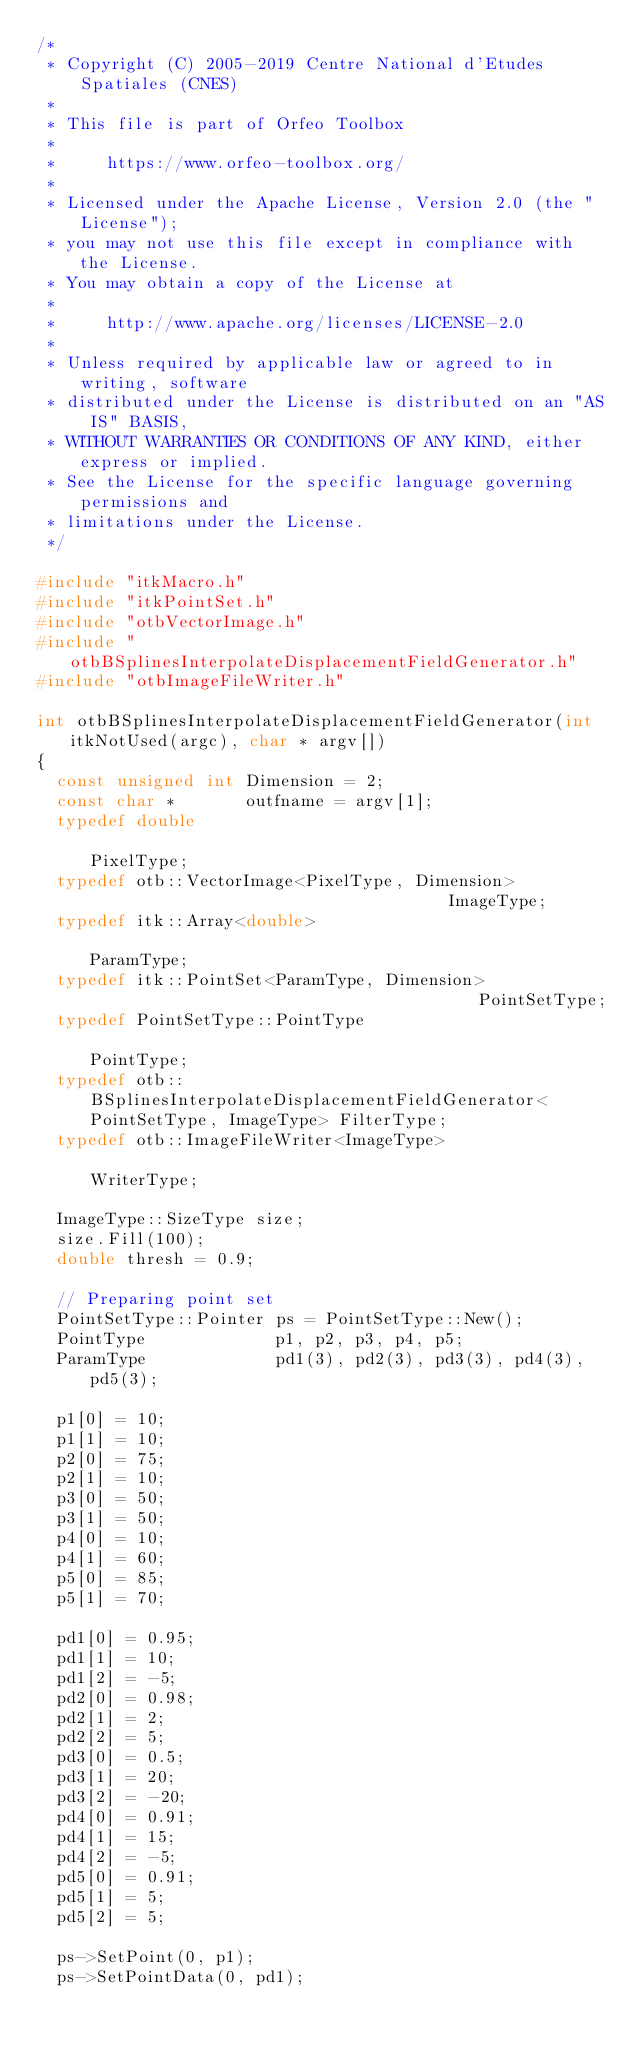<code> <loc_0><loc_0><loc_500><loc_500><_C++_>/*
 * Copyright (C) 2005-2019 Centre National d'Etudes Spatiales (CNES)
 *
 * This file is part of Orfeo Toolbox
 *
 *     https://www.orfeo-toolbox.org/
 *
 * Licensed under the Apache License, Version 2.0 (the "License");
 * you may not use this file except in compliance with the License.
 * You may obtain a copy of the License at
 *
 *     http://www.apache.org/licenses/LICENSE-2.0
 *
 * Unless required by applicable law or agreed to in writing, software
 * distributed under the License is distributed on an "AS IS" BASIS,
 * WITHOUT WARRANTIES OR CONDITIONS OF ANY KIND, either express or implied.
 * See the License for the specific language governing permissions and
 * limitations under the License.
 */

#include "itkMacro.h"
#include "itkPointSet.h"
#include "otbVectorImage.h"
#include "otbBSplinesInterpolateDisplacementFieldGenerator.h"
#include "otbImageFileWriter.h"

int otbBSplinesInterpolateDisplacementFieldGenerator(int itkNotUsed(argc), char * argv[])
{
  const unsigned int Dimension = 2;
  const char *       outfname = argv[1];
  typedef double                                                                     PixelType;
  typedef otb::VectorImage<PixelType, Dimension>                                     ImageType;
  typedef itk::Array<double>                                                         ParamType;
  typedef itk::PointSet<ParamType, Dimension>                                        PointSetType;
  typedef PointSetType::PointType                                                    PointType;
  typedef otb::BSplinesInterpolateDisplacementFieldGenerator<PointSetType, ImageType> FilterType;
  typedef otb::ImageFileWriter<ImageType>                                            WriterType;

  ImageType::SizeType size;
  size.Fill(100);
  double thresh = 0.9;

  // Preparing point set
  PointSetType::Pointer ps = PointSetType::New();
  PointType             p1, p2, p3, p4, p5;
  ParamType             pd1(3), pd2(3), pd3(3), pd4(3), pd5(3);

  p1[0] = 10;
  p1[1] = 10;
  p2[0] = 75;
  p2[1] = 10;
  p3[0] = 50;
  p3[1] = 50;
  p4[0] = 10;
  p4[1] = 60;
  p5[0] = 85;
  p5[1] = 70;

  pd1[0] = 0.95;
  pd1[1] = 10;
  pd1[2] = -5;
  pd2[0] = 0.98;
  pd2[1] = 2;
  pd2[2] = 5;
  pd3[0] = 0.5;
  pd3[1] = 20;
  pd3[2] = -20;
  pd4[0] = 0.91;
  pd4[1] = 15;
  pd4[2] = -5;
  pd5[0] = 0.91;
  pd5[1] = 5;
  pd5[2] = 5;

  ps->SetPoint(0, p1);
  ps->SetPointData(0, pd1);</code> 